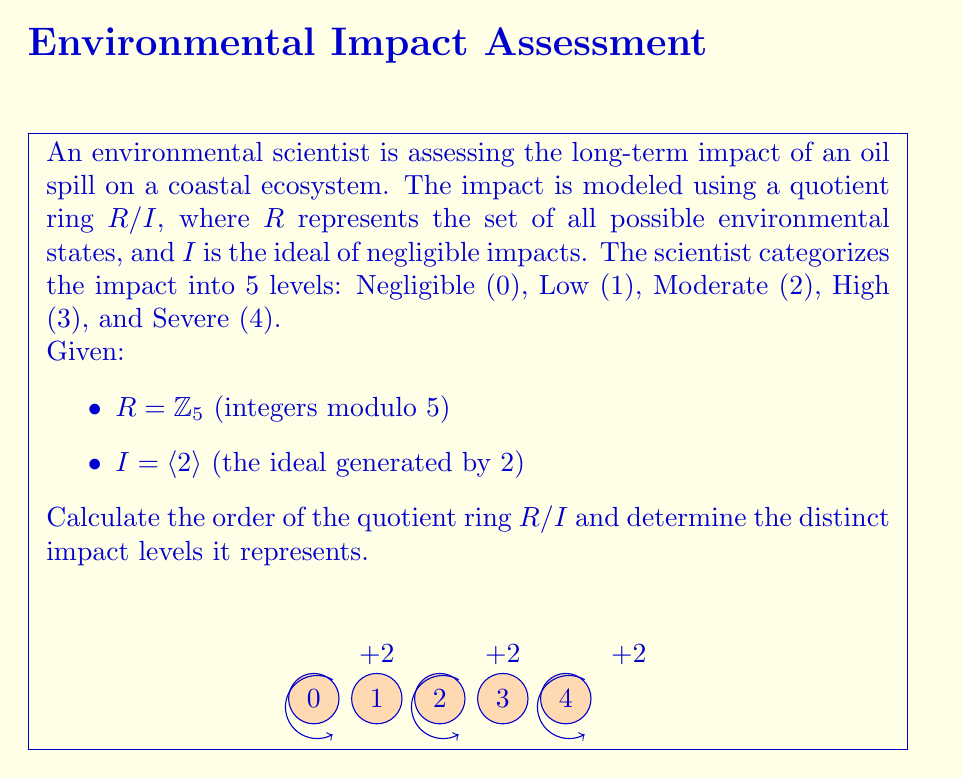Could you help me with this problem? To solve this problem, we need to follow these steps:

1) First, let's understand what the quotient ring $R/I$ represents:
   - $R = \mathbb{Z}_5$ is the ring of integers modulo 5
   - $I = \langle 2 \rangle$ is the ideal generated by 2

2) The elements of $I$ are multiples of 2 in $\mathbb{Z}_5$:
   $I = \{0, 2, 4, 1, 3\}$ (because $2 \cdot 2 = 4$, $2 \cdot 3 = 1$, $2 \cdot 4 = 3$ in $\mathbb{Z}_5$)

3) The quotient ring $R/I$ consists of cosets of $I$ in $R$. Two elements are in the same coset if their difference is in $I$.

4) To find the distinct cosets, we add each element of $R$ to $I$:
   $0 + I = \{0, 2, 4, 1, 3\} = I$
   $1 + I = \{1, 3, 0, 2, 4\} = I$
   $2 + I = \{2, 4, 1, 3, 0\} = I$
   $3 + I = \{3, 0, 2, 4, 1\} = I$
   $4 + I = \{4, 1, 3, 0, 2\} = I$

5) We see that all cosets are equal to $I$ itself. This means $R/I$ has only one element, the coset $I$.

6) Therefore, the order of $R/I$ is 1.

7) In terms of impact levels, this means that all impact levels are considered equivalent under this model. The quotient ring reduces all impacts to a single category, effectively treating all non-negligible impacts as indistinguishable.
Answer: Order of $R/I$: 1; Distinct impact levels: 1 (all impacts equivalent) 